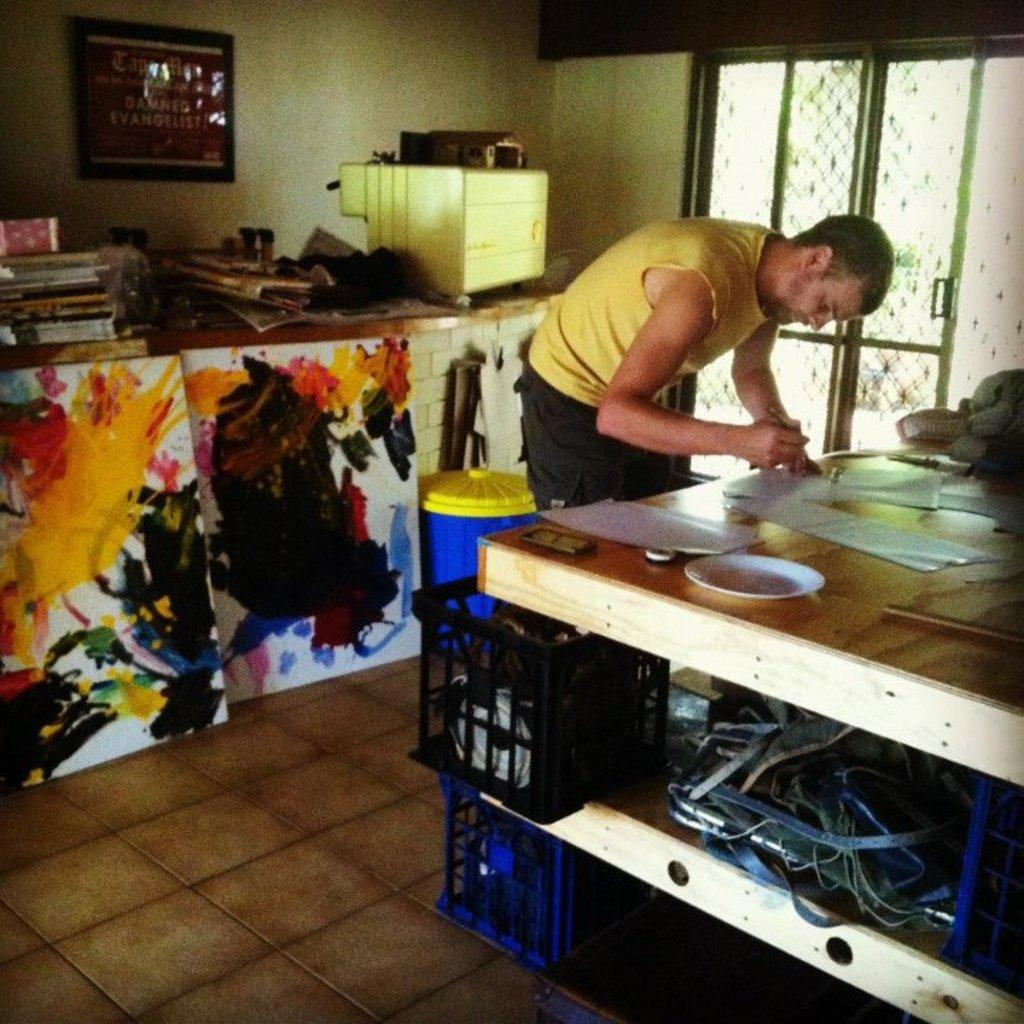What is the main setting of the image? There is a room in the image. Who or what can be seen in the room? A person is present in the room. What is the person doing in the room? The person is doing something, but we cannot determine the specific activity from the facts provided. What is in front of the person in the room? There is a table in front of the person. What items are on the table in the image? There are different items on the table, but the specific items are not mentioned in the facts provided. How does the person show respect to the camp in the image? There is no camp present in the image, and therefore the person cannot show respect to a camp. 